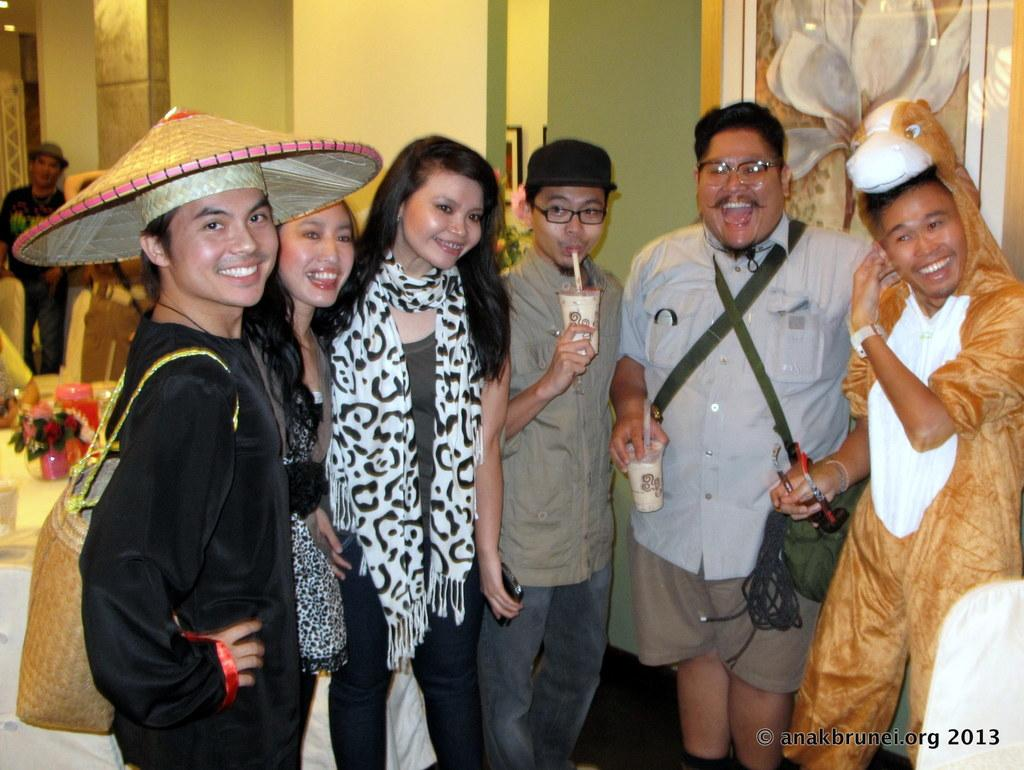What is the main subject of the image? The main subject of the image is a group of people. What are the people in the image doing? The people are standing and smiling. Where is the text located in the image? The text is in the right-hand side bottom of the image. What type of silk is being used to create the paste in the vein of the image? There is no silk, paste, or vein present in the image. 